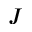<formula> <loc_0><loc_0><loc_500><loc_500>J</formula> 